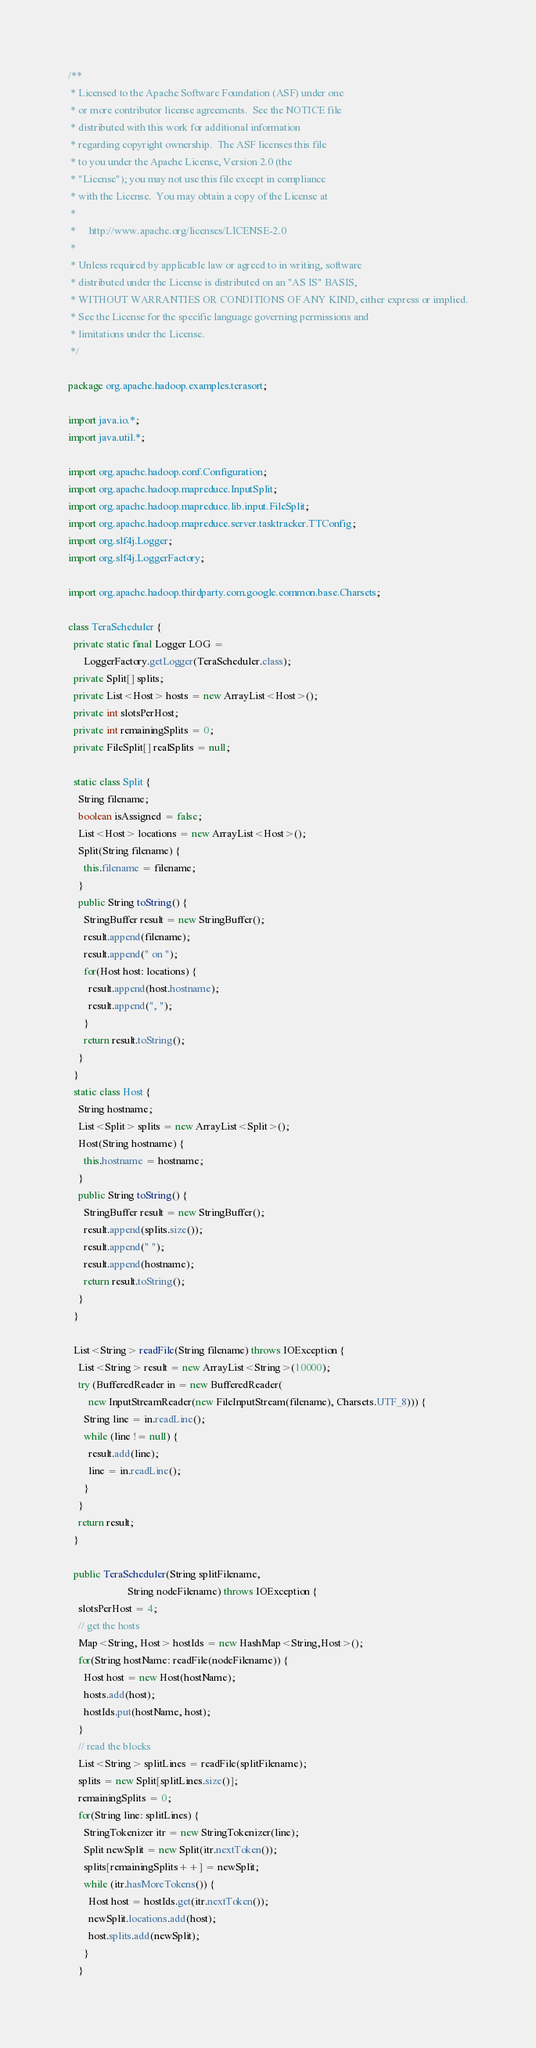<code> <loc_0><loc_0><loc_500><loc_500><_Java_>/**
 * Licensed to the Apache Software Foundation (ASF) under one
 * or more contributor license agreements.  See the NOTICE file
 * distributed with this work for additional information
 * regarding copyright ownership.  The ASF licenses this file
 * to you under the Apache License, Version 2.0 (the
 * "License"); you may not use this file except in compliance
 * with the License.  You may obtain a copy of the License at
 *
 *     http://www.apache.org/licenses/LICENSE-2.0
 *
 * Unless required by applicable law or agreed to in writing, software
 * distributed under the License is distributed on an "AS IS" BASIS,
 * WITHOUT WARRANTIES OR CONDITIONS OF ANY KIND, either express or implied.
 * See the License for the specific language governing permissions and
 * limitations under the License.
 */

package org.apache.hadoop.examples.terasort;

import java.io.*;
import java.util.*;

import org.apache.hadoop.conf.Configuration;
import org.apache.hadoop.mapreduce.InputSplit;
import org.apache.hadoop.mapreduce.lib.input.FileSplit;
import org.apache.hadoop.mapreduce.server.tasktracker.TTConfig;
import org.slf4j.Logger;
import org.slf4j.LoggerFactory;

import org.apache.hadoop.thirdparty.com.google.common.base.Charsets;

class TeraScheduler {
  private static final Logger LOG =
      LoggerFactory.getLogger(TeraScheduler.class);
  private Split[] splits;
  private List<Host> hosts = new ArrayList<Host>();
  private int slotsPerHost;
  private int remainingSplits = 0;
  private FileSplit[] realSplits = null;

  static class Split {
    String filename;
    boolean isAssigned = false;
    List<Host> locations = new ArrayList<Host>();
    Split(String filename) {
      this.filename = filename;
    }
    public String toString() {
      StringBuffer result = new StringBuffer();
      result.append(filename);
      result.append(" on ");
      for(Host host: locations) {
        result.append(host.hostname);
        result.append(", ");
      }
      return result.toString();
    }
  }
  static class Host {
    String hostname;
    List<Split> splits = new ArrayList<Split>();
    Host(String hostname) {
      this.hostname = hostname;
    }
    public String toString() {
      StringBuffer result = new StringBuffer();
      result.append(splits.size());
      result.append(" ");
      result.append(hostname);
      return result.toString();
    }
  }

  List<String> readFile(String filename) throws IOException {
    List<String> result = new ArrayList<String>(10000);
    try (BufferedReader in = new BufferedReader(
        new InputStreamReader(new FileInputStream(filename), Charsets.UTF_8))) {
      String line = in.readLine();
      while (line != null) {
        result.add(line);
        line = in.readLine();
      }
    }
    return result;
  }

  public TeraScheduler(String splitFilename, 
                       String nodeFilename) throws IOException {
    slotsPerHost = 4;
    // get the hosts
    Map<String, Host> hostIds = new HashMap<String,Host>();
    for(String hostName: readFile(nodeFilename)) {
      Host host = new Host(hostName);
      hosts.add(host);
      hostIds.put(hostName, host);
    }
    // read the blocks
    List<String> splitLines = readFile(splitFilename);
    splits = new Split[splitLines.size()];
    remainingSplits = 0;
    for(String line: splitLines) {
      StringTokenizer itr = new StringTokenizer(line);
      Split newSplit = new Split(itr.nextToken());
      splits[remainingSplits++] = newSplit;
      while (itr.hasMoreTokens()) {
        Host host = hostIds.get(itr.nextToken());
        newSplit.locations.add(host);
        host.splits.add(newSplit);
      }
    }</code> 